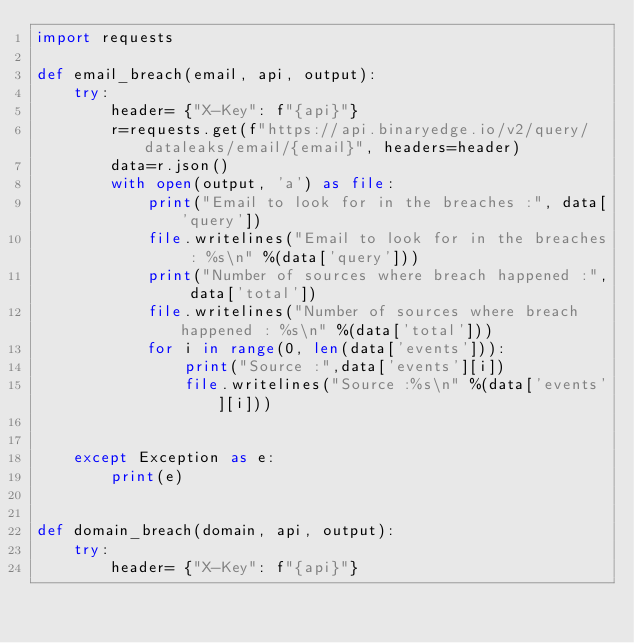<code> <loc_0><loc_0><loc_500><loc_500><_Python_>import requests

def email_breach(email, api, output):
    try:
        header= {"X-Key": f"{api}"}
        r=requests.get(f"https://api.binaryedge.io/v2/query/dataleaks/email/{email}", headers=header)
        data=r.json()
        with open(output, 'a') as file:
            print("Email to look for in the breaches :", data['query'])
            file.writelines("Email to look for in the breaches : %s\n" %(data['query']))
            print("Number of sources where breach happened :", data['total'])
            file.writelines("Number of sources where breach happened : %s\n" %(data['total']))
            for i in range(0, len(data['events'])):
                print("Source :",data['events'][i])
                file.writelines("Source :%s\n" %(data['events'][i]))
            

    except Exception as e:
        print(e)


def domain_breach(domain, api, output):
    try:
        header= {"X-Key": f"{api}"}</code> 